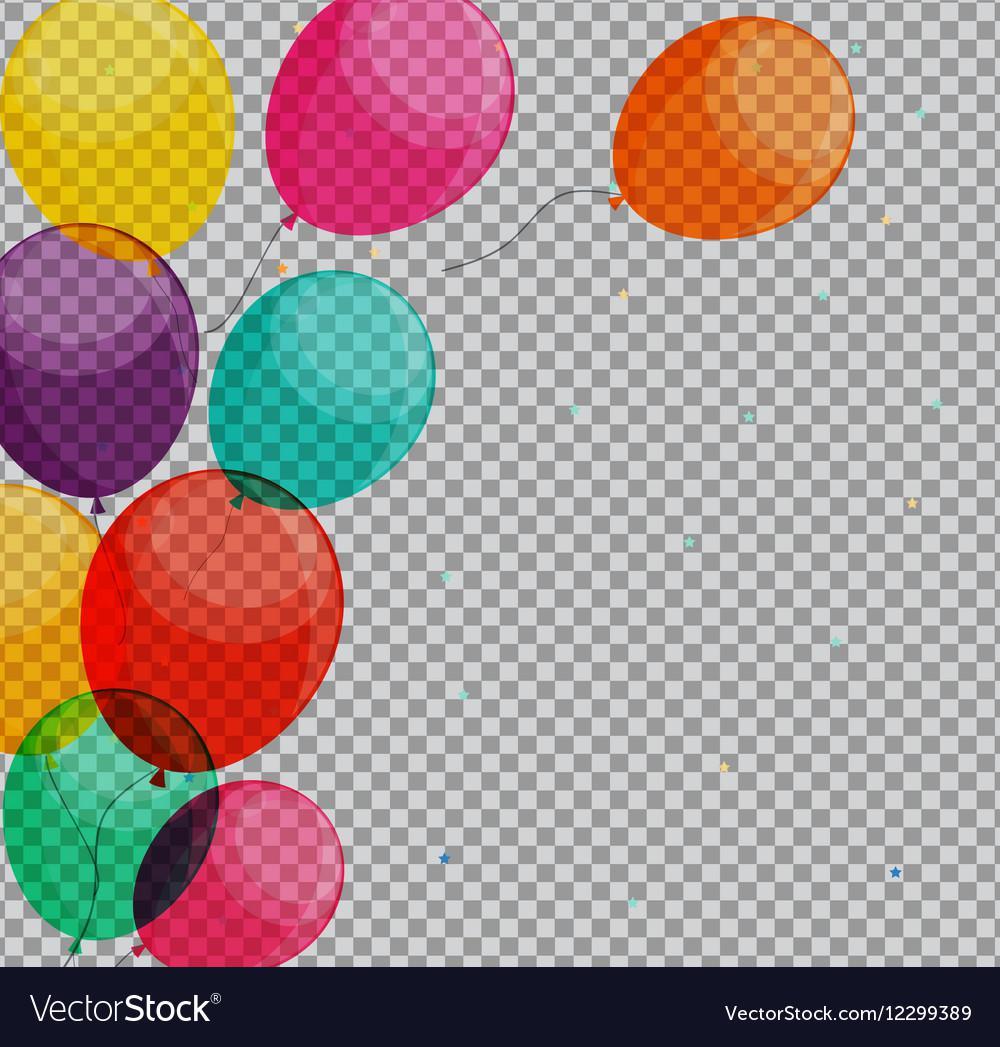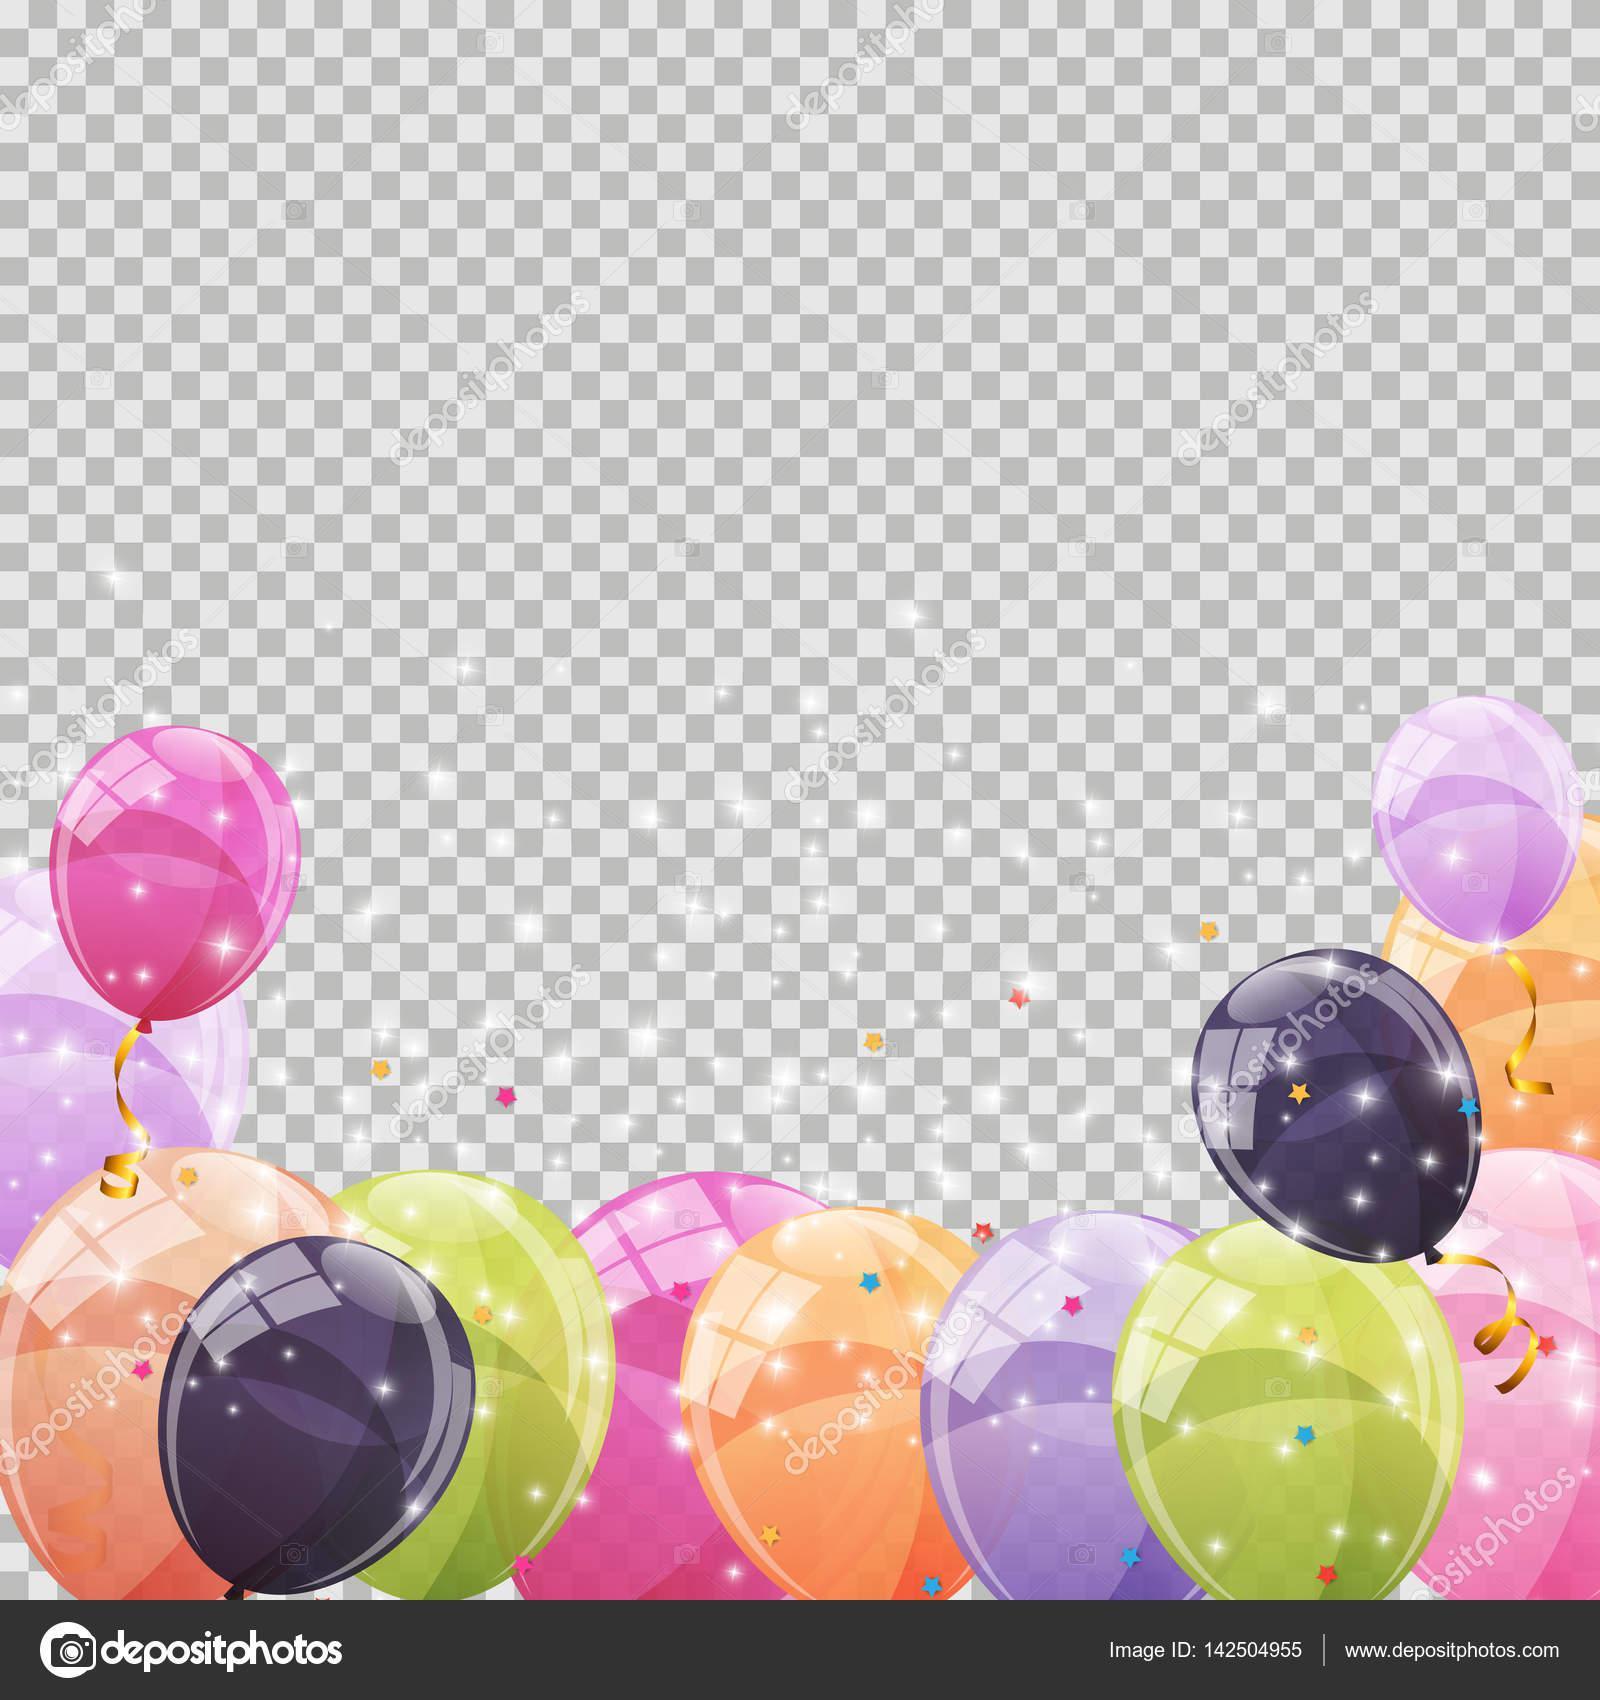The first image is the image on the left, the second image is the image on the right. Considering the images on both sides, is "One image shows round balloons with dangling, non-straight strings under them, and contains no more than four balloons." valid? Answer yes or no. No. 